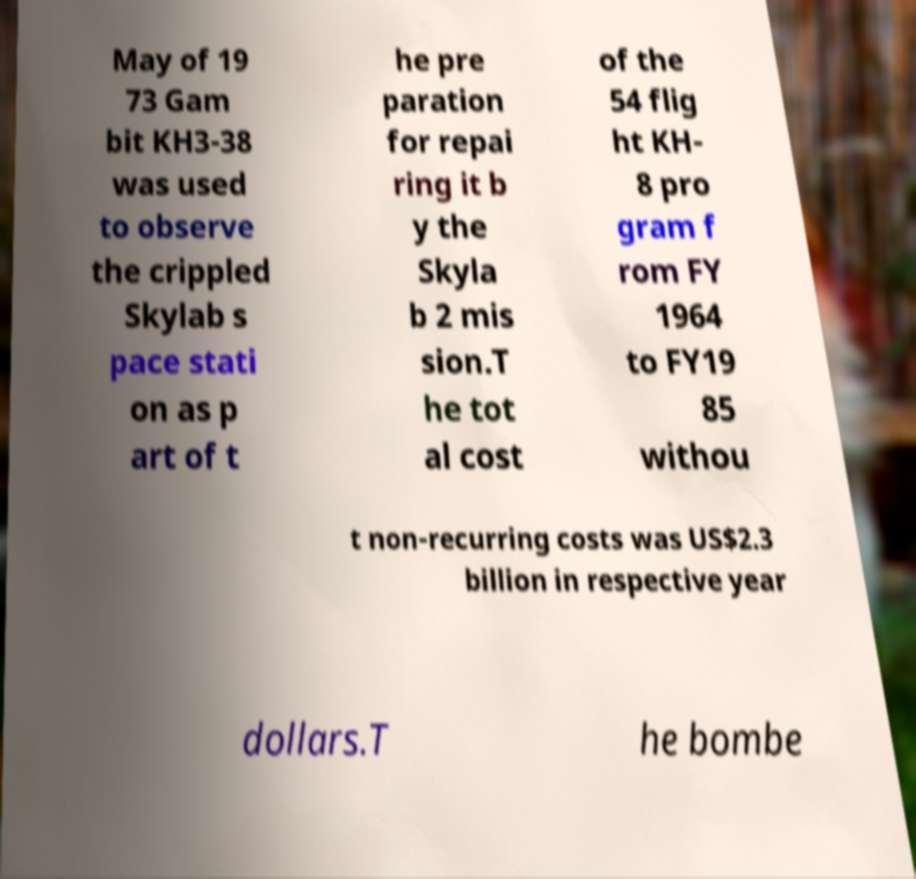Could you extract and type out the text from this image? May of 19 73 Gam bit KH3-38 was used to observe the crippled Skylab s pace stati on as p art of t he pre paration for repai ring it b y the Skyla b 2 mis sion.T he tot al cost of the 54 flig ht KH- 8 pro gram f rom FY 1964 to FY19 85 withou t non-recurring costs was US$2.3 billion in respective year dollars.T he bombe 